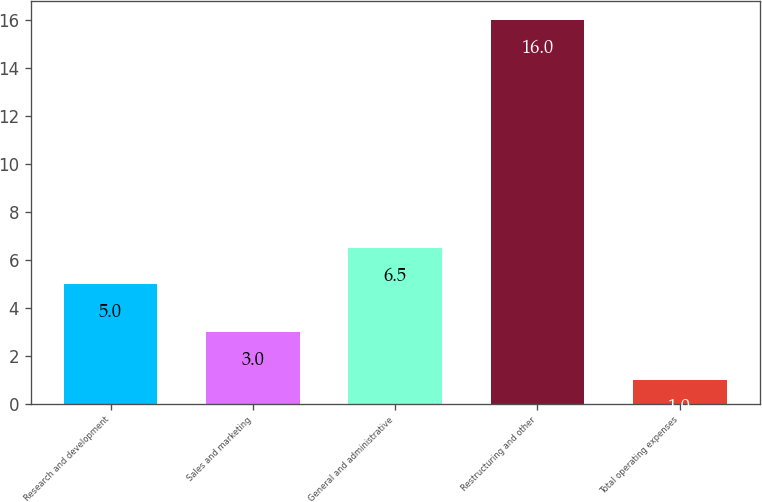<chart> <loc_0><loc_0><loc_500><loc_500><bar_chart><fcel>Research and development<fcel>Sales and marketing<fcel>General and administrative<fcel>Restructuring and other<fcel>Total operating expenses<nl><fcel>5<fcel>3<fcel>6.5<fcel>16<fcel>1<nl></chart> 